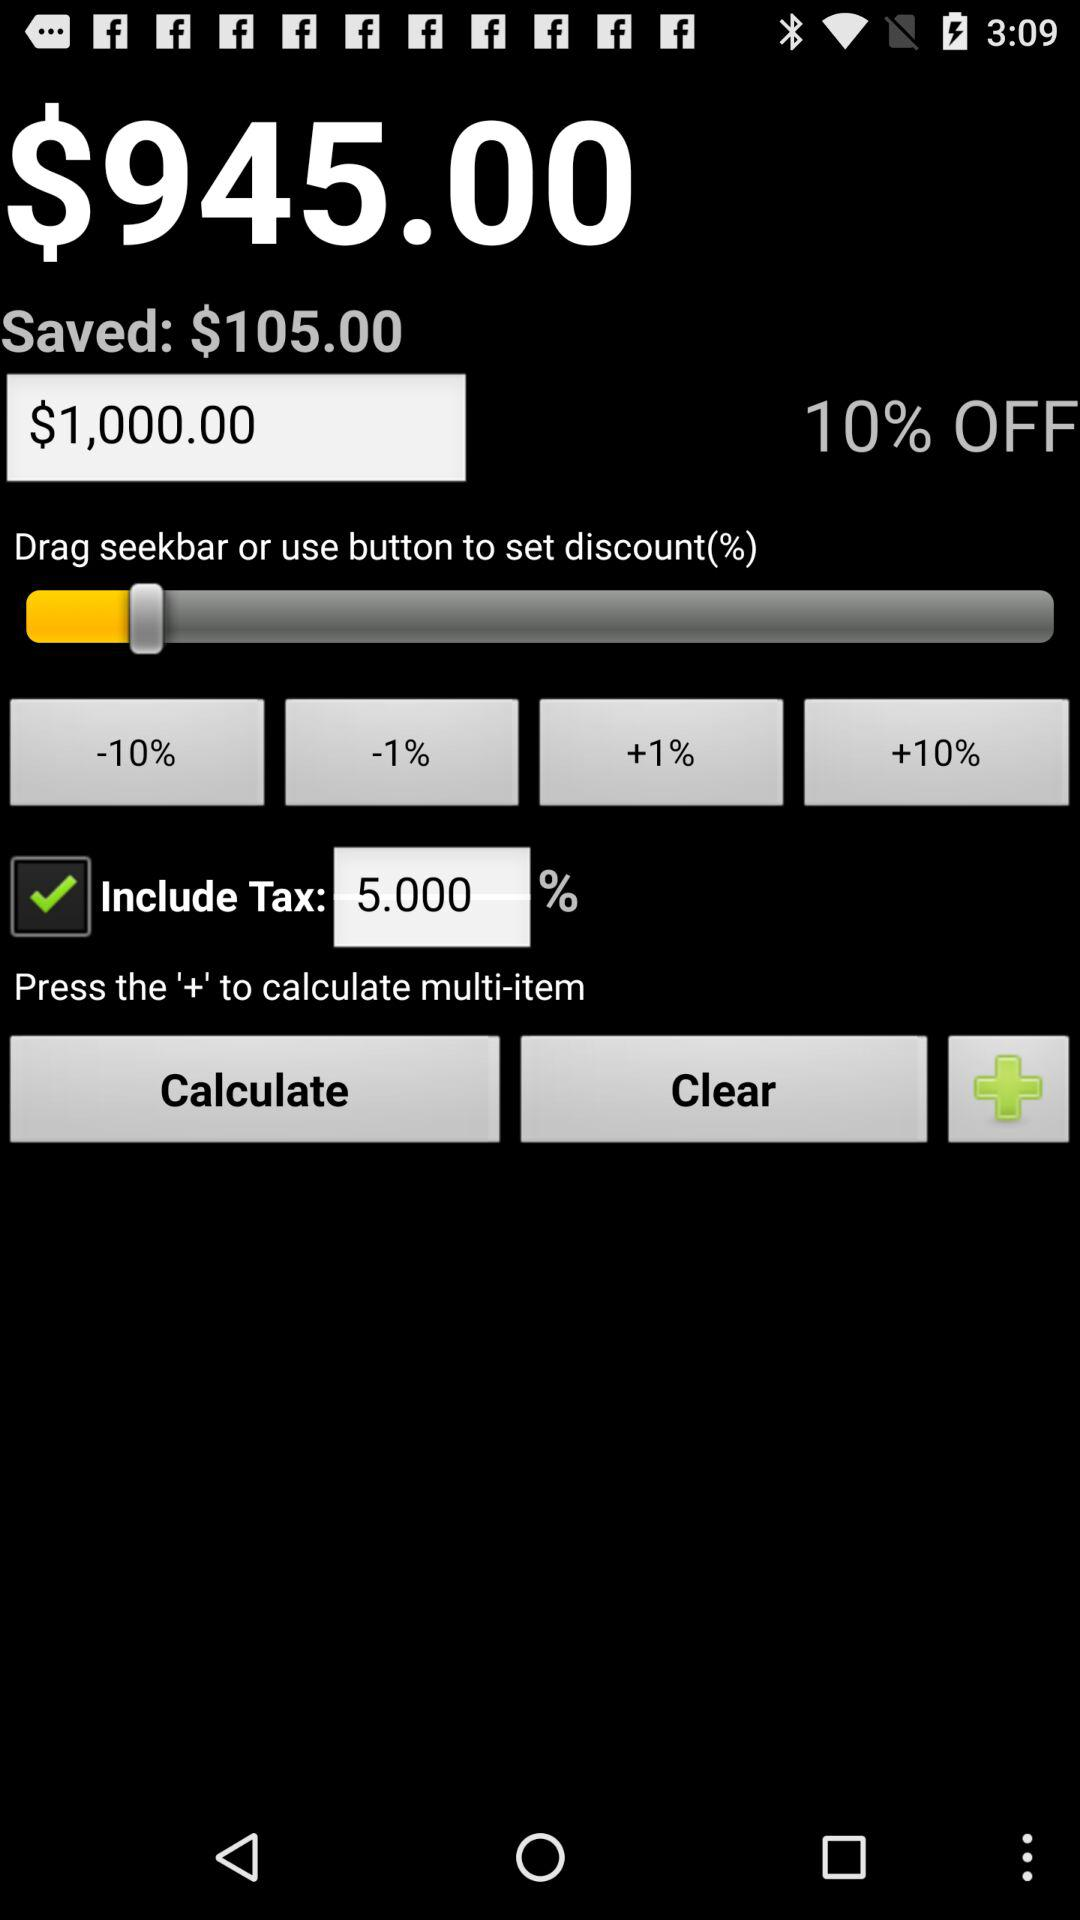What is the selected discount percentage? The selected discount percentage is 10. 